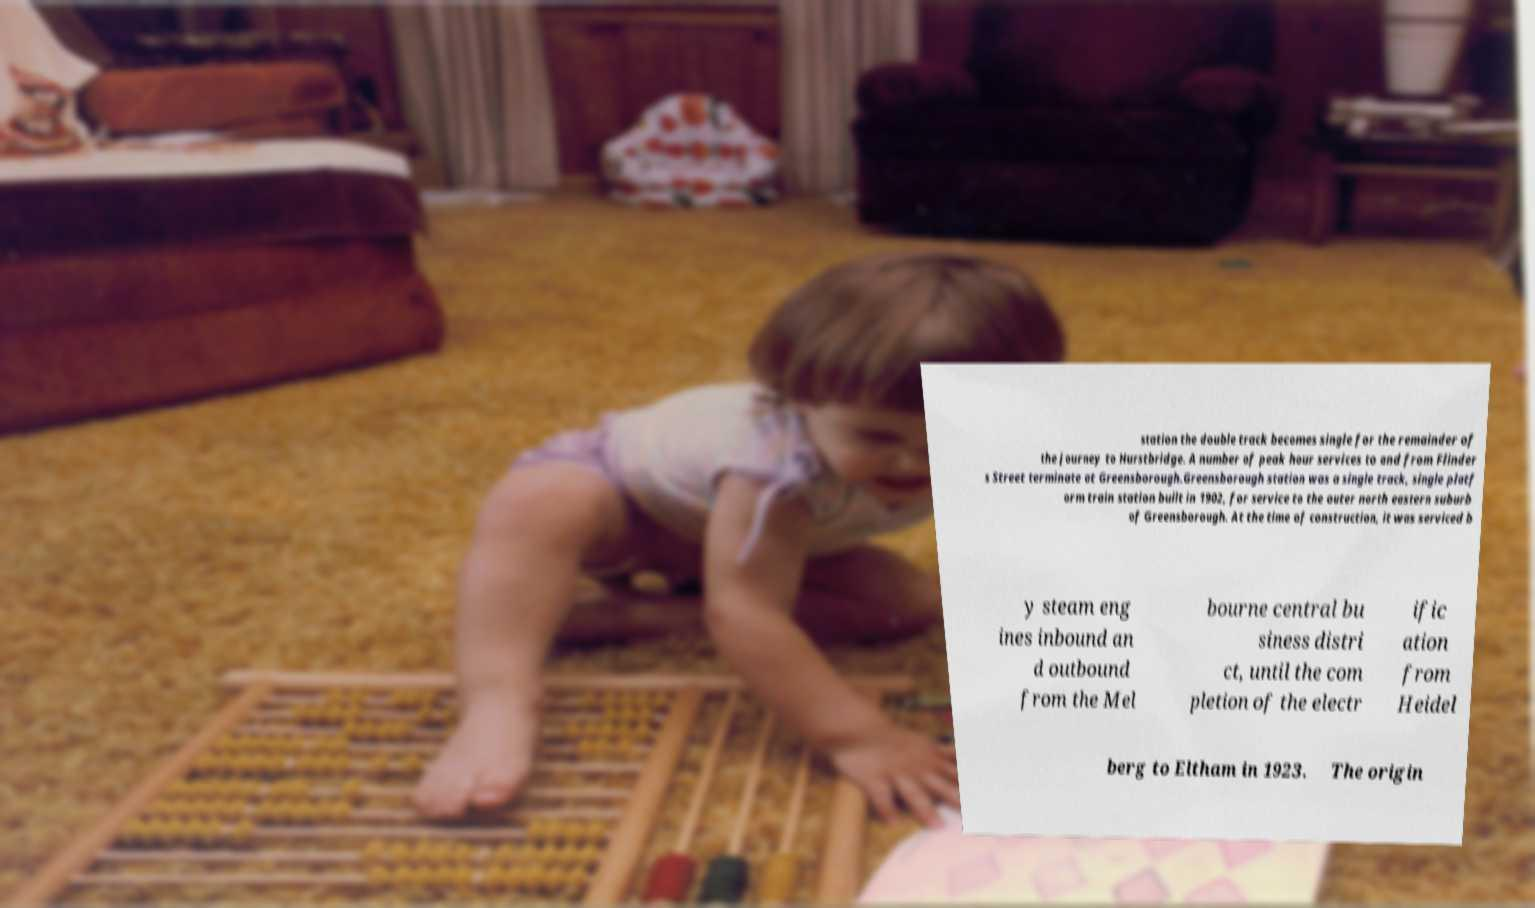Can you accurately transcribe the text from the provided image for me? station the double track becomes single for the remainder of the journey to Hurstbridge. A number of peak hour services to and from Flinder s Street terminate at Greensborough.Greensborough station was a single track, single platf orm train station built in 1902, for service to the outer north eastern suburb of Greensborough. At the time of construction, it was serviced b y steam eng ines inbound an d outbound from the Mel bourne central bu siness distri ct, until the com pletion of the electr ific ation from Heidel berg to Eltham in 1923. The origin 